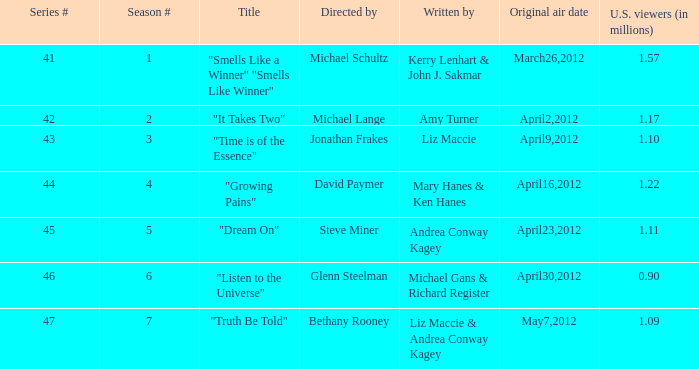22 million u.s. audience members? "Growing Pains". Write the full table. {'header': ['Series #', 'Season #', 'Title', 'Directed by', 'Written by', 'Original air date', 'U.S. viewers (in millions)'], 'rows': [['41', '1', '"Smells Like a Winner" "Smells Like Winner"', 'Michael Schultz', 'Kerry Lenhart & John J. Sakmar', 'March26,2012', '1.57'], ['42', '2', '"It Takes Two"', 'Michael Lange', 'Amy Turner', 'April2,2012', '1.17'], ['43', '3', '"Time is of the Essence"', 'Jonathan Frakes', 'Liz Maccie', 'April9,2012', '1.10'], ['44', '4', '"Growing Pains"', 'David Paymer', 'Mary Hanes & Ken Hanes', 'April16,2012', '1.22'], ['45', '5', '"Dream On"', 'Steve Miner', 'Andrea Conway Kagey', 'April23,2012', '1.11'], ['46', '6', '"Listen to the Universe"', 'Glenn Steelman', 'Michael Gans & Richard Register', 'April30,2012', '0.90'], ['47', '7', '"Truth Be Told"', 'Bethany Rooney', 'Liz Maccie & Andrea Conway Kagey', 'May7,2012', '1.09']]} 